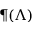<formula> <loc_0><loc_0><loc_500><loc_500>\P ( \Lambda )</formula> 